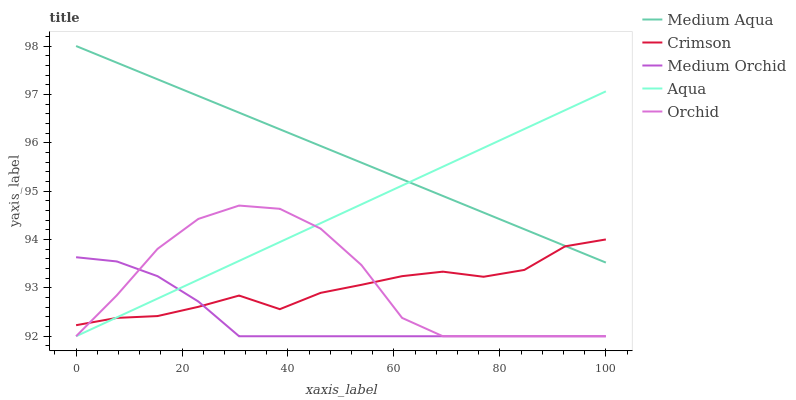Does Aqua have the minimum area under the curve?
Answer yes or no. No. Does Aqua have the maximum area under the curve?
Answer yes or no. No. Is Aqua the smoothest?
Answer yes or no. No. Is Aqua the roughest?
Answer yes or no. No. Does Medium Aqua have the lowest value?
Answer yes or no. No. Does Aqua have the highest value?
Answer yes or no. No. Is Orchid less than Medium Aqua?
Answer yes or no. Yes. Is Medium Aqua greater than Medium Orchid?
Answer yes or no. Yes. Does Orchid intersect Medium Aqua?
Answer yes or no. No. 